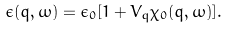<formula> <loc_0><loc_0><loc_500><loc_500>\epsilon ( q , \omega ) = \epsilon _ { 0 } [ 1 + V _ { q } \chi _ { 0 } ( q , \omega ) ] .</formula> 